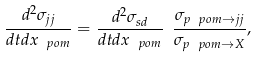<formula> <loc_0><loc_0><loc_500><loc_500>\frac { d ^ { 2 } \sigma _ { j j } } { d t d x _ { \ p o m } } = \frac { d ^ { 2 } \sigma _ { s d } } { d t d x _ { \ p o m } } \ \frac { \sigma _ { p \ p o m \rightarrow j j } } { \sigma _ { p \ p o m \rightarrow X } } ,</formula> 